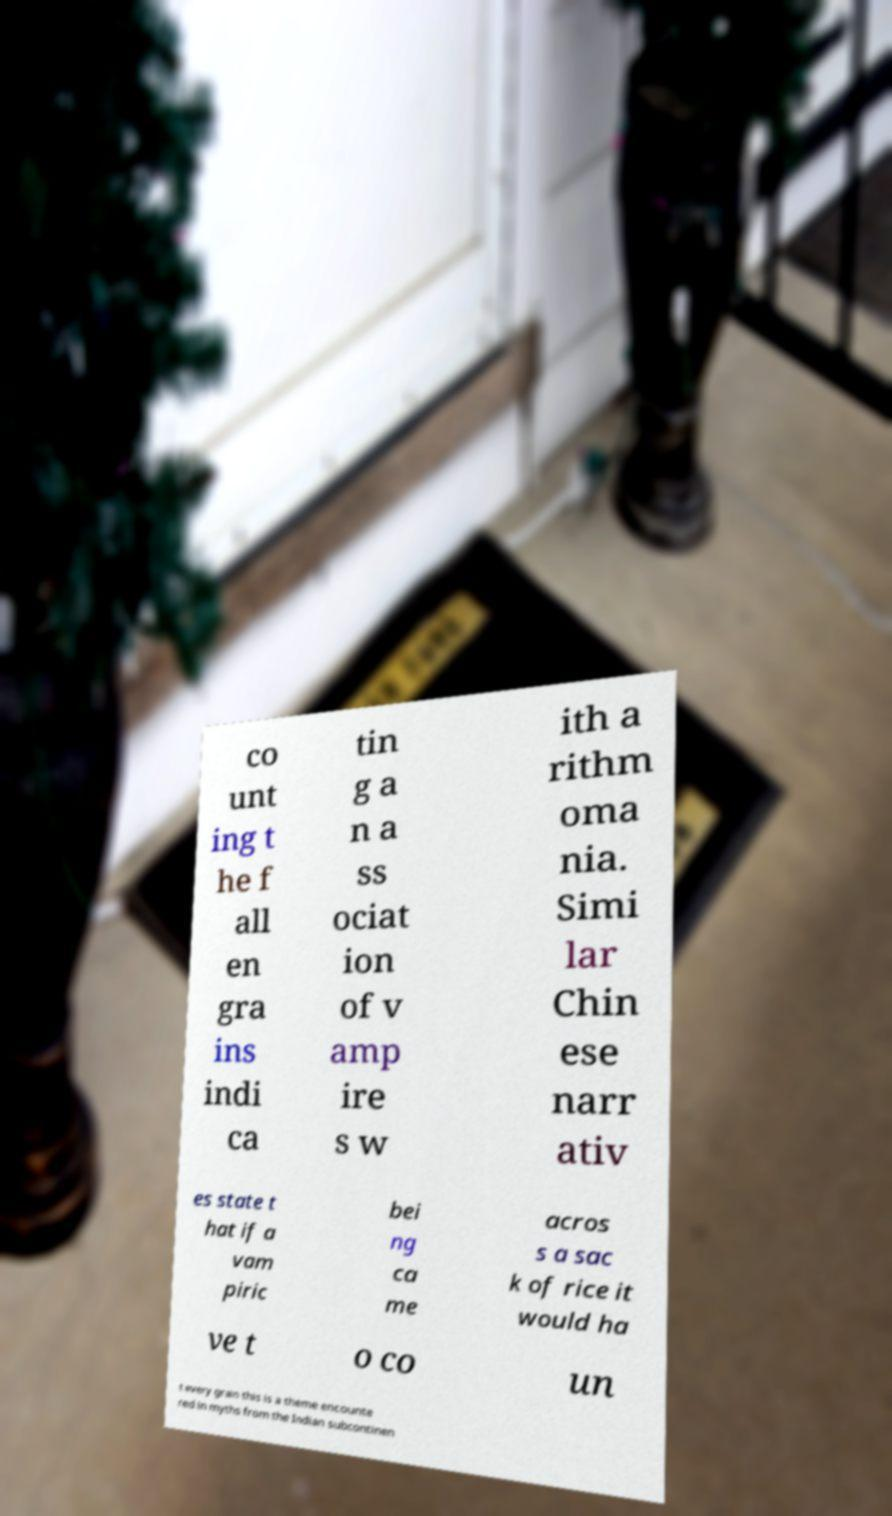Can you accurately transcribe the text from the provided image for me? co unt ing t he f all en gra ins indi ca tin g a n a ss ociat ion of v amp ire s w ith a rithm oma nia. Simi lar Chin ese narr ativ es state t hat if a vam piric bei ng ca me acros s a sac k of rice it would ha ve t o co un t every grain this is a theme encounte red in myths from the Indian subcontinen 